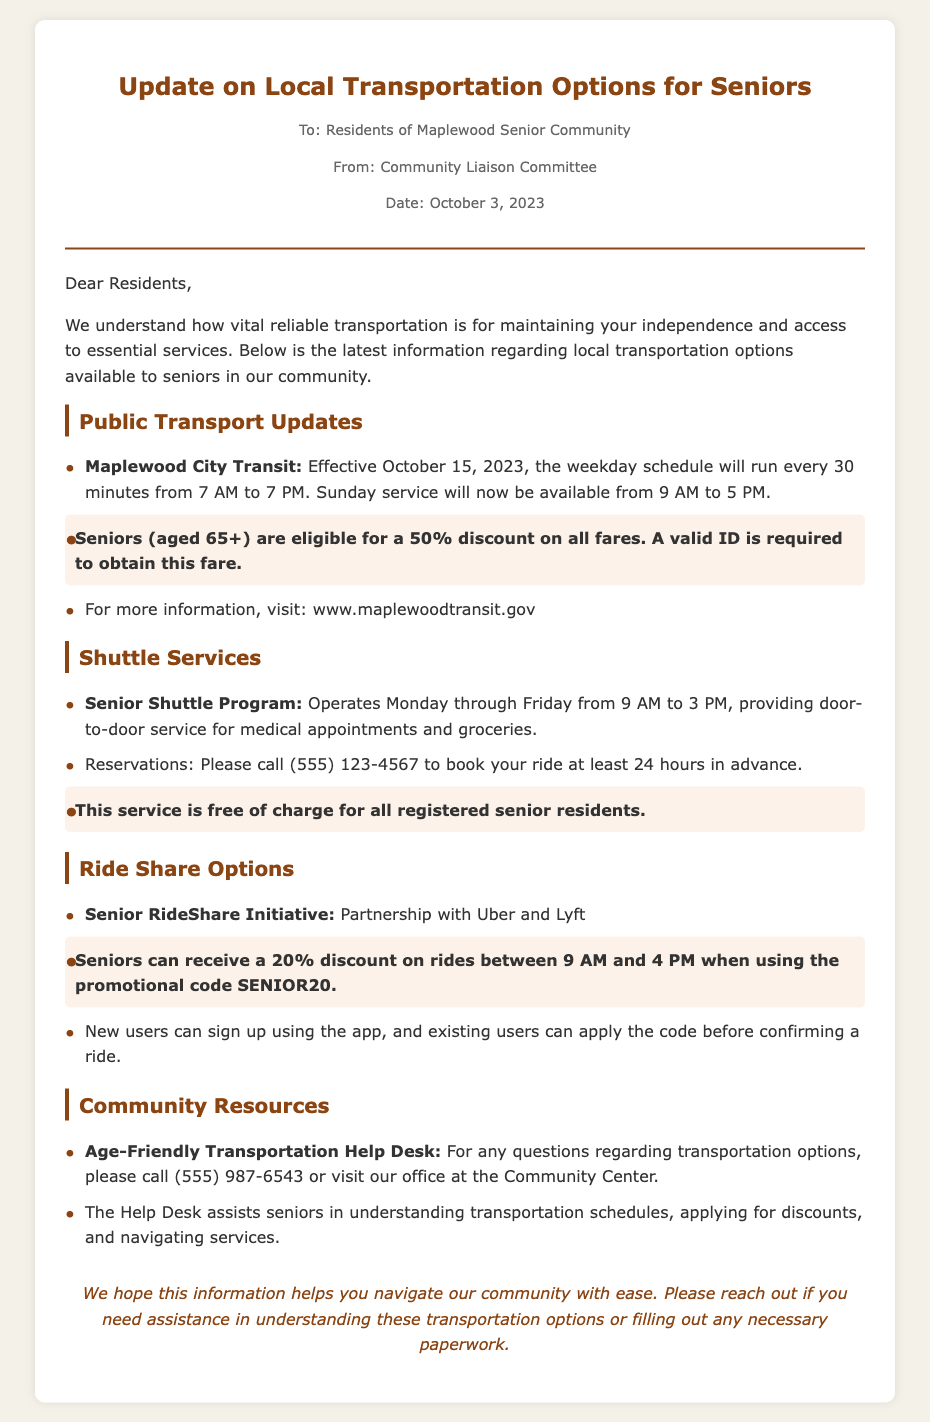What is the effective date of the new Maplewood City Transit schedule? The effective date for the new schedule is mentioned in the document as October 15, 2023.
Answer: October 15, 2023 What discount do seniors receive on Maplewood City Transit fares? The document specifies that seniors are eligible for a 50% discount on all fares.
Answer: 50% What time does Senior Shuttle Program operate? The operating hours for the Senior Shuttle Program are detailed in the document as Monday through Friday from 9 AM to 3 PM.
Answer: 9 AM to 3 PM What is the promotional code for the Senior RideShare Initiative discount? The document highlights that the promotional code for the discount is SENIOR20.
Answer: SENIOR20 How many hours in advance should reservations be made for the Senior Shuttle Program? The memo states that reservations should be made at least 24 hours in advance.
Answer: 24 hours What is the free service provided for registered senior residents? The document indicates that registered senior residents can use the Senior Shuttle Program free of charge.
Answer: Free of charge Which Help Desk number can seniors call for transportation questions? The document provides the Help Desk number as (555) 987-6543 for transportation questions.
Answer: (555) 987-6543 What is the discount percentage for seniors using the RideShare options? The document mentions that seniors can receive a 20% discount on rides between 9 AM and 4 PM.
Answer: 20% What does the concluding statement emphasize in the memo? The conclusion states the hope that the information helps residents navigate the community with ease and offers assistance.
Answer: Assistance 